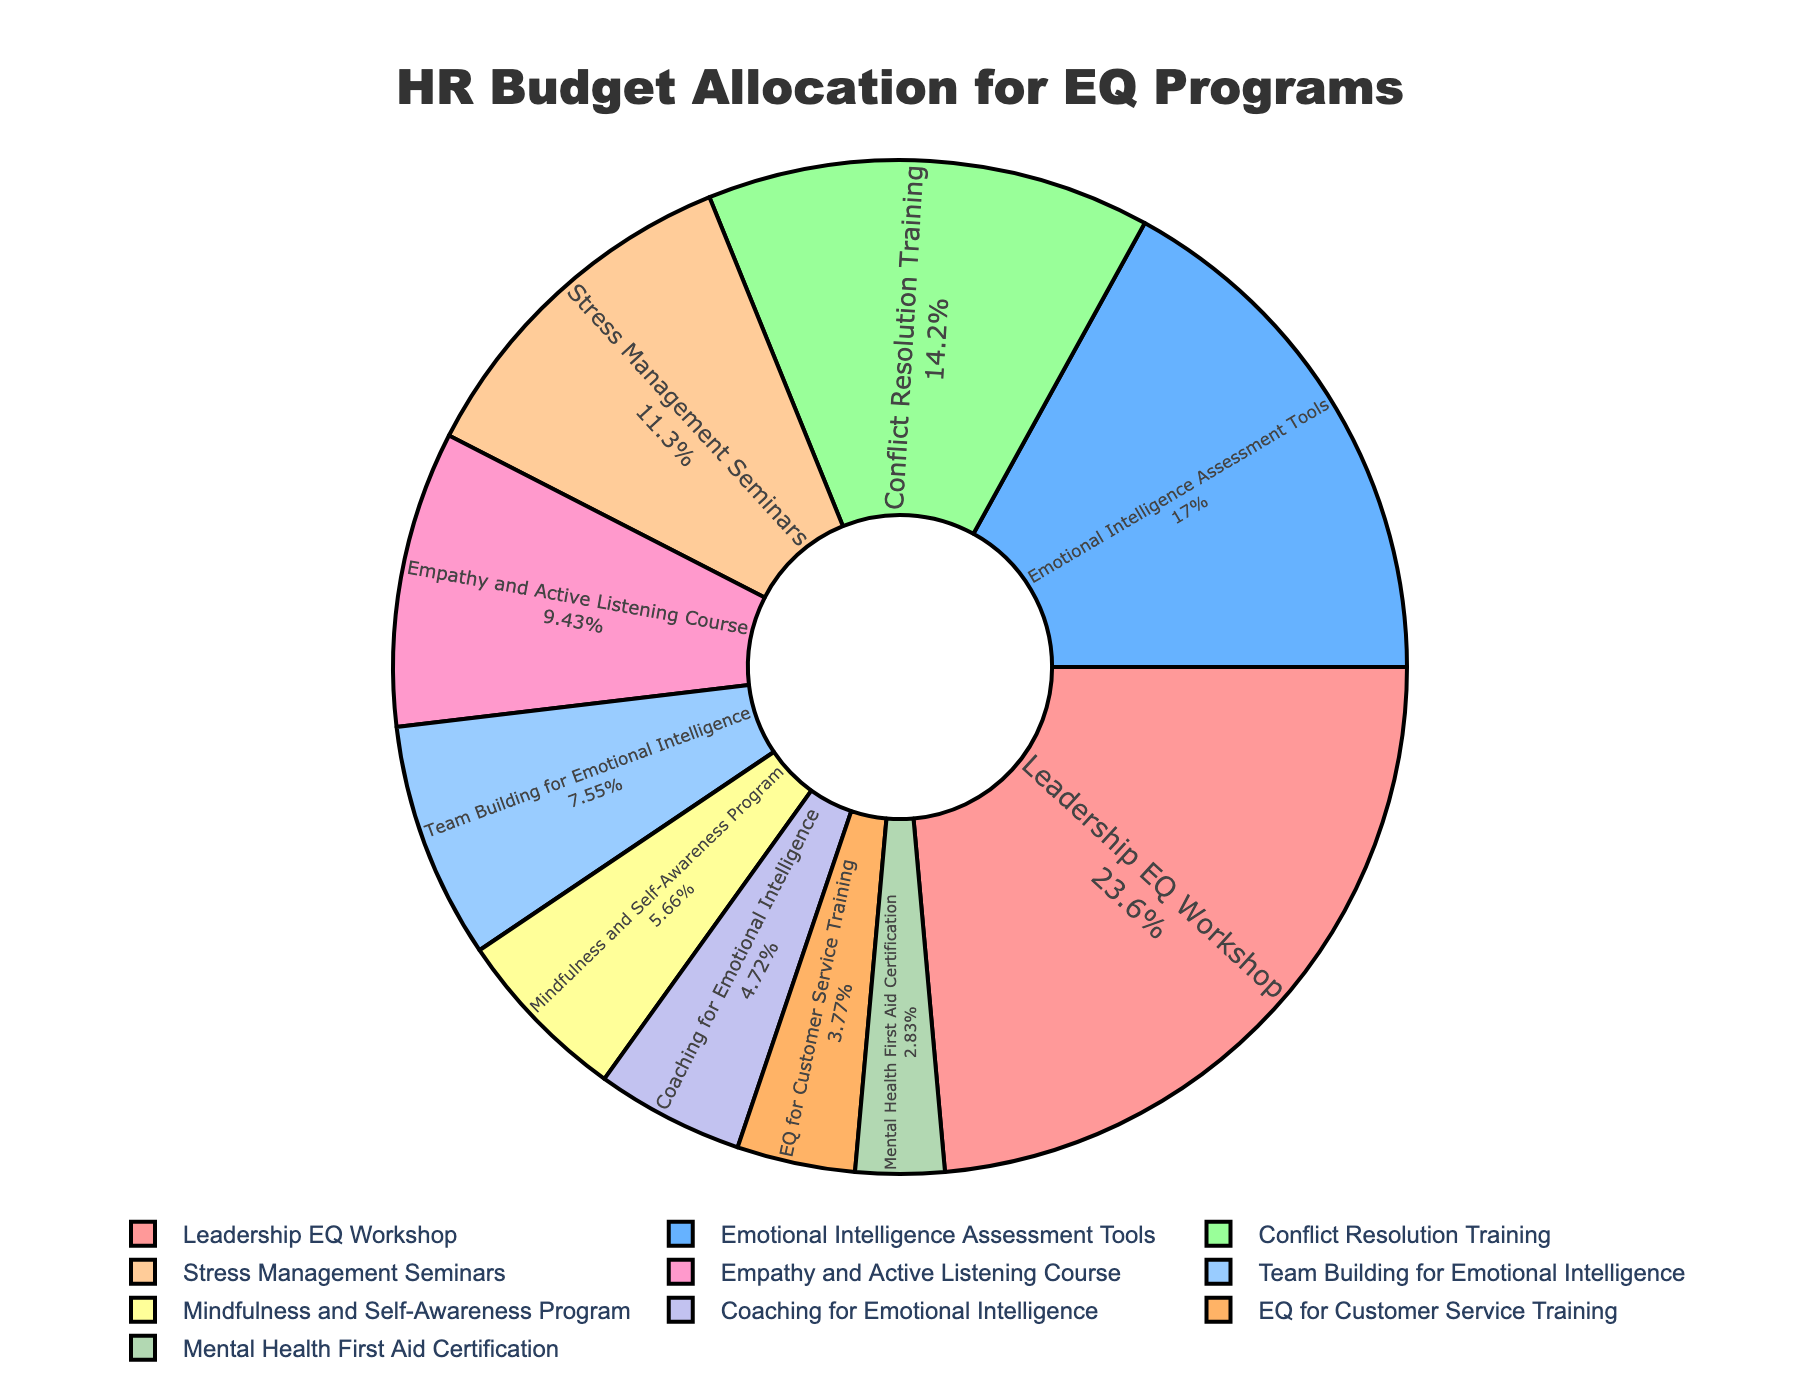Which EQ program has the highest budget allocation? The pie chart shows the budget allocation for each EQ program. By looking at the sizes of the slices, we can see that the 'Leadership EQ Workshop' has the largest slice.
Answer: Leadership EQ Workshop How much total budget is allocated to 'Conflict Resolution Training' and 'Stress Management Seminars' combined? The budget allocation for 'Conflict Resolution Training' is 15, and for 'Stress Management Seminars' is 12. Summing these values gives us 15 + 12 = 27.
Answer: 27 Which program receives less budget: 'Empathy and Active Listening Course' or 'Team Building for Emotional Intelligence'? By comparing the slices for 'Empathy and Active Listening Course' and 'Team Building for Emotional Intelligence', we can see that the 'Team Building for Emotional Intelligence' receives less budget.
Answer: Team Building for Emotional Intelligence Are there more programs above or below 10% allocation? The chart indicates the percent allocation for each program. By counting, 'Leadership EQ Workshop' and 'Emotional Intelligence Assessment Tools' are above 10%, while 'Conflict Resolution Training', 'Stress Management Seminars', 'Empathy and Active Listening Course', 'Team Building for Emotional Intelligence', 'Mindfulness and Self-Awareness Program', 'Coaching for Emotional Intelligence', 'EQ for Customer Service Training', and 'Mental Health First Aid Certification' are below 10%. There are 8 programs below 10% and 2 programs above 10%.
Answer: Below 10% What percent of the budget is allocated to 'Mindfulness and Self-Awareness Program'? The pie chart includes text indicating the percent budget for each program. 'Mindfulness and Self-Awareness Program' has 6% of the total budget.
Answer: 6% Which section of the pie chart is the smallest, and what is its budget allocation percentage? The smallest section of the pie chart is the one labeled 'Mental Health First Aid Certification', which indicates a 3% budget allocation.
Answer: Mental Health First Aid Certification, 3% How does the budget allocation for 'Coaching for Emotional Intelligence' compare to 'EQ for Customer Service Training'? The pie chart allows us to compare the size of slices for each program. 'Coaching for Emotional Intelligence' has a larger slice than 'EQ for Customer Service Training', meaning it has a higher budget allocation.
Answer: Coaching for Emotional Intelligence has a higher budget allocation Determine the average budget allocation for all the EQ programs. To find the average budget allocation, sum all the allocations (25+18+15+12+10+8+6+5+4+3=106) and divide by the number of programs (10). The average allocation is 106/10 = 10.6.
Answer: 10.6 Is the slice for 'Leadership EQ Workshop' more than twice the size of 'Empathy and Active Listening Course'? The allocation for 'Leadership EQ Workshop' is 25 and for 'Empathy and Active Listening Course' is 10. Doubling 'Empathy and Active Listening Course' allocation gives 2*10 = 20, which is less than 25. Therefore, 'Leadership EQ Workshop' is more than twice the size.
Answer: Yes 